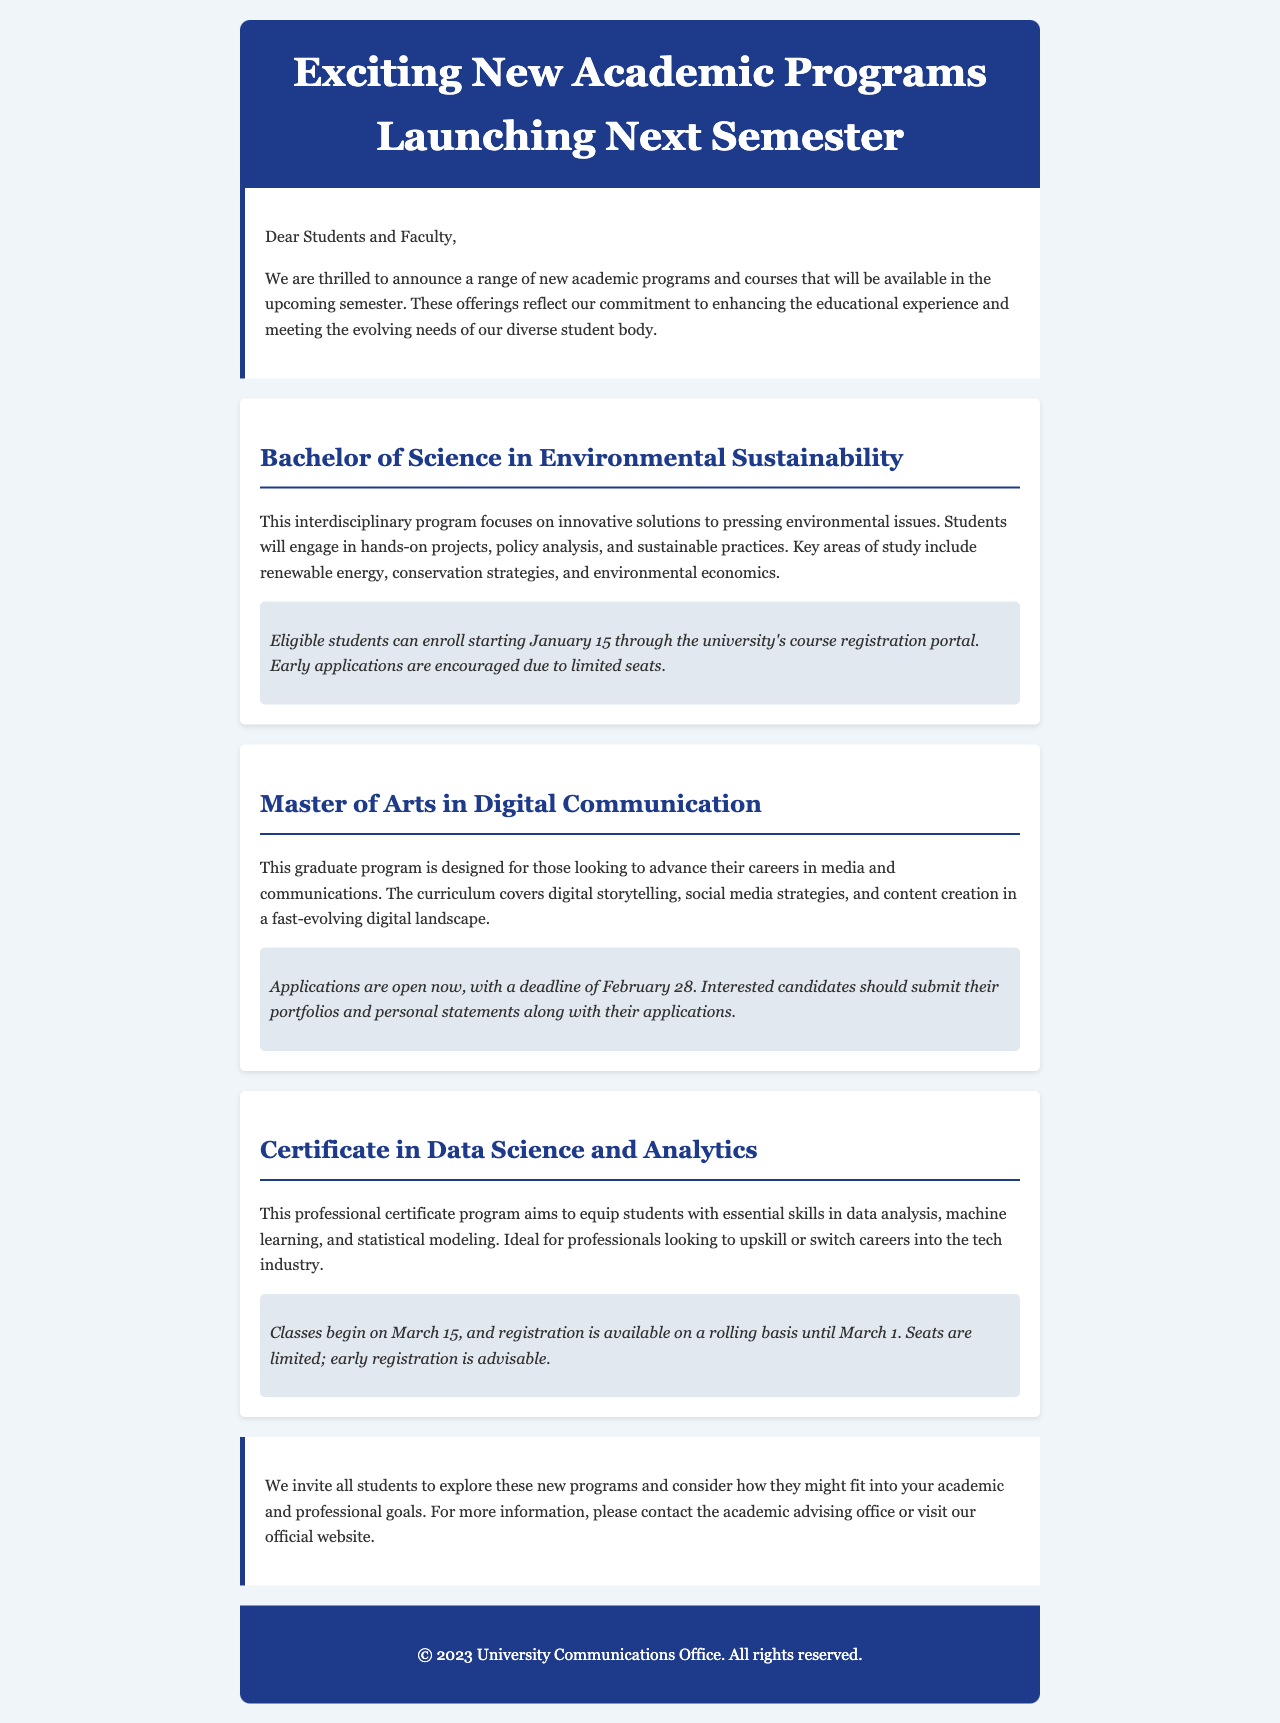What is the title of the new Bachelor's program? The title of the new Bachelor's program is presented in the document as "Bachelor of Science in Environmental Sustainability."
Answer: Bachelor of Science in Environmental Sustainability When does registration open for the Master's program? The document states that applications for the Master's program are open now.
Answer: Now What is the deadline for applying to the Master of Arts in Digital Communication? The document specifies that the deadline for applications is February 28.
Answer: February 28 What date do classes begin for the Certificate in Data Science and Analytics? The document indicates that classes for the certificate program begin on March 15.
Answer: March 15 How many total new programs are mentioned in the newsletter? The document lists three new programs: Bachelor's, Master's, and Certificate.
Answer: Three What is one of the key areas of study in the Environmental Sustainability program? The document mentions several key areas, such as renewable energy, conservation strategies, and environmental economics.
Answer: Renewable energy What type of students is the Certificate in Data Science and Analytics aimed at? The document describes the certificate program as ideal for professionals looking to upskill or switch careers into the tech industry.
Answer: Professionals What type of document is this? The content format of the document is a newsletter intended for communication regarding new academic offerings.
Answer: Newsletter 